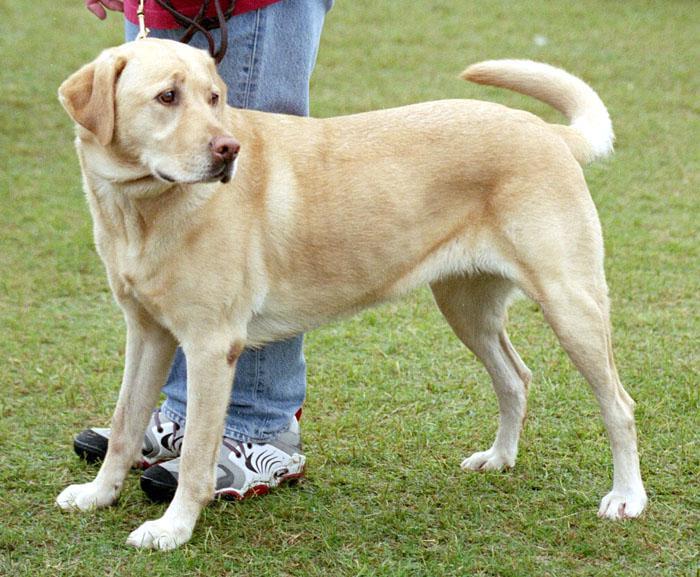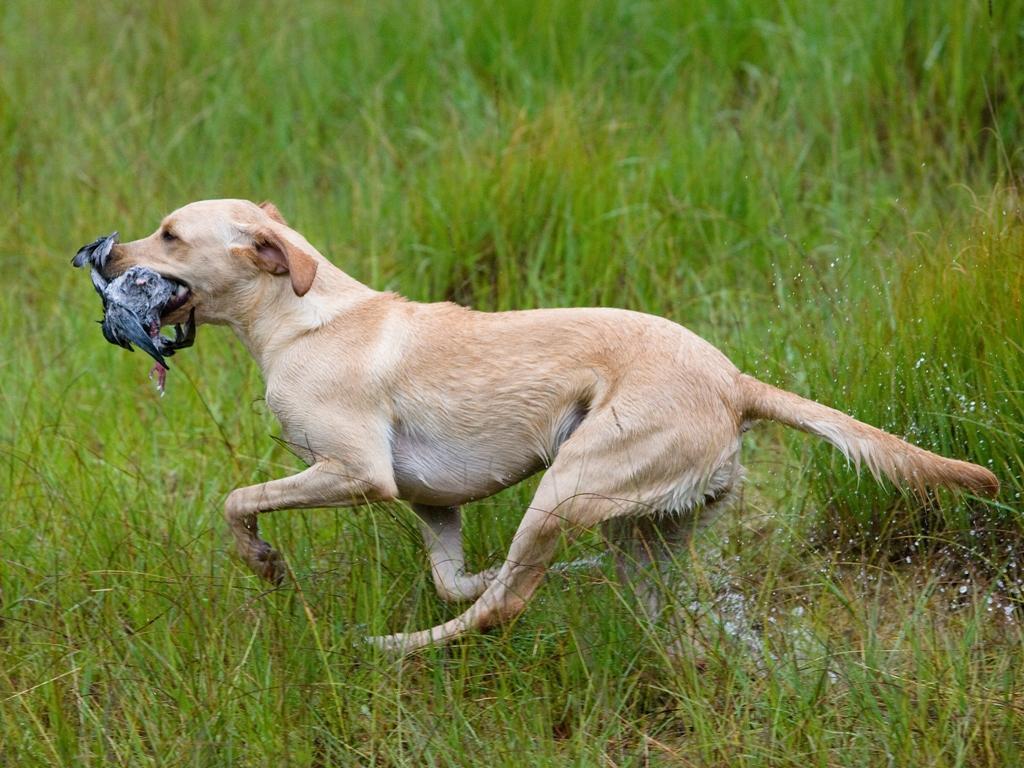The first image is the image on the left, the second image is the image on the right. Assess this claim about the two images: "In one image in each pair an upright dog has something in its mouth.". Correct or not? Answer yes or no. Yes. The first image is the image on the left, the second image is the image on the right. Given the left and right images, does the statement "A dog is carrying something in its mouth." hold true? Answer yes or no. Yes. 